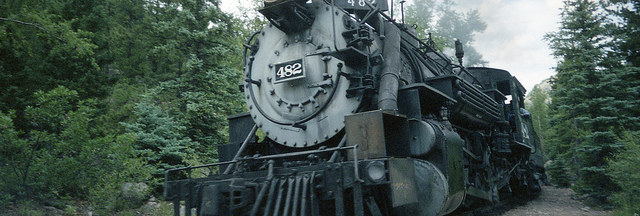Identify and read out the text in this image. 482 